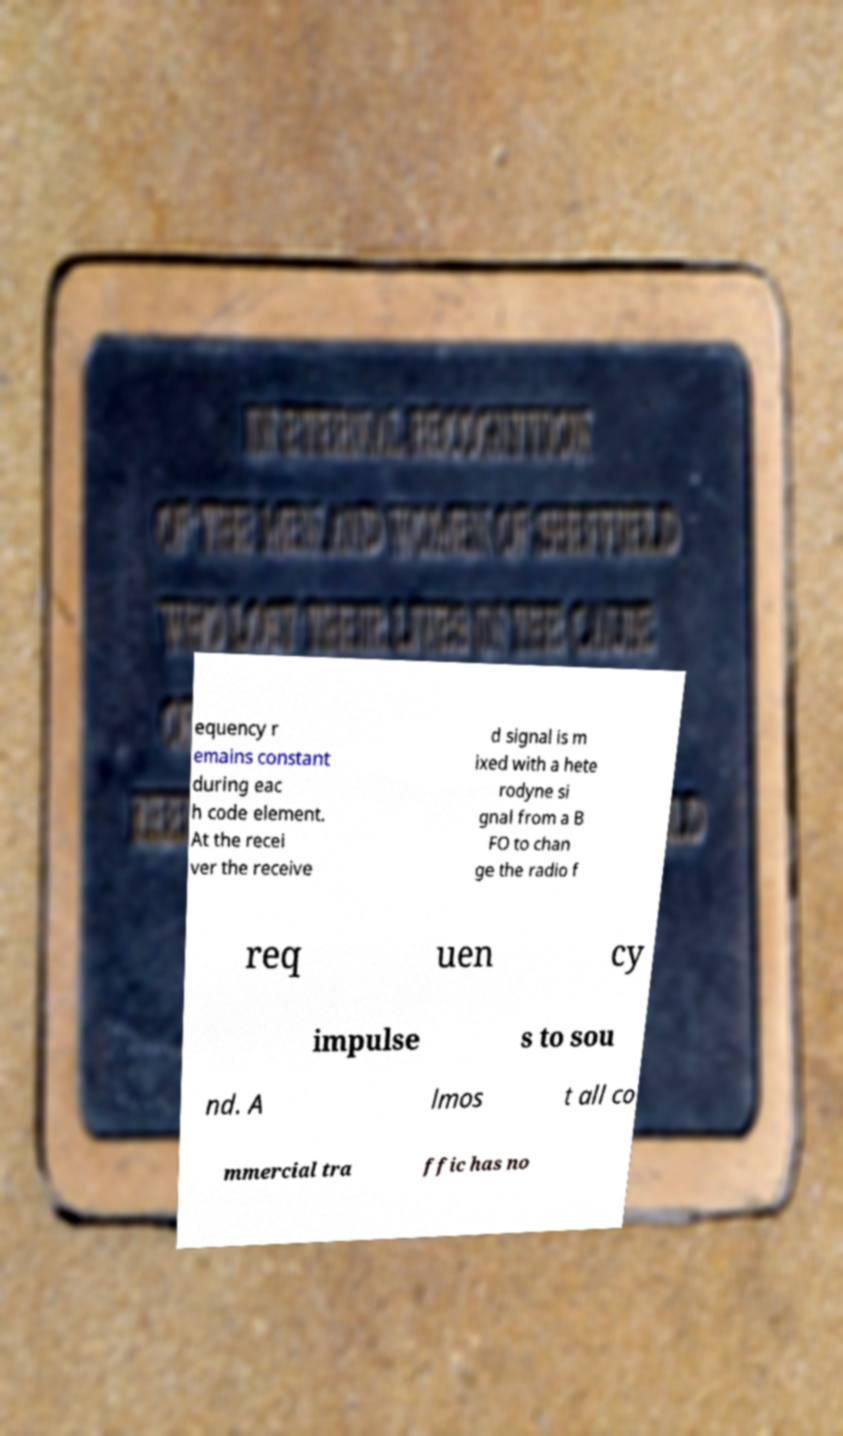I need the written content from this picture converted into text. Can you do that? equency r emains constant during eac h code element. At the recei ver the receive d signal is m ixed with a hete rodyne si gnal from a B FO to chan ge the radio f req uen cy impulse s to sou nd. A lmos t all co mmercial tra ffic has no 